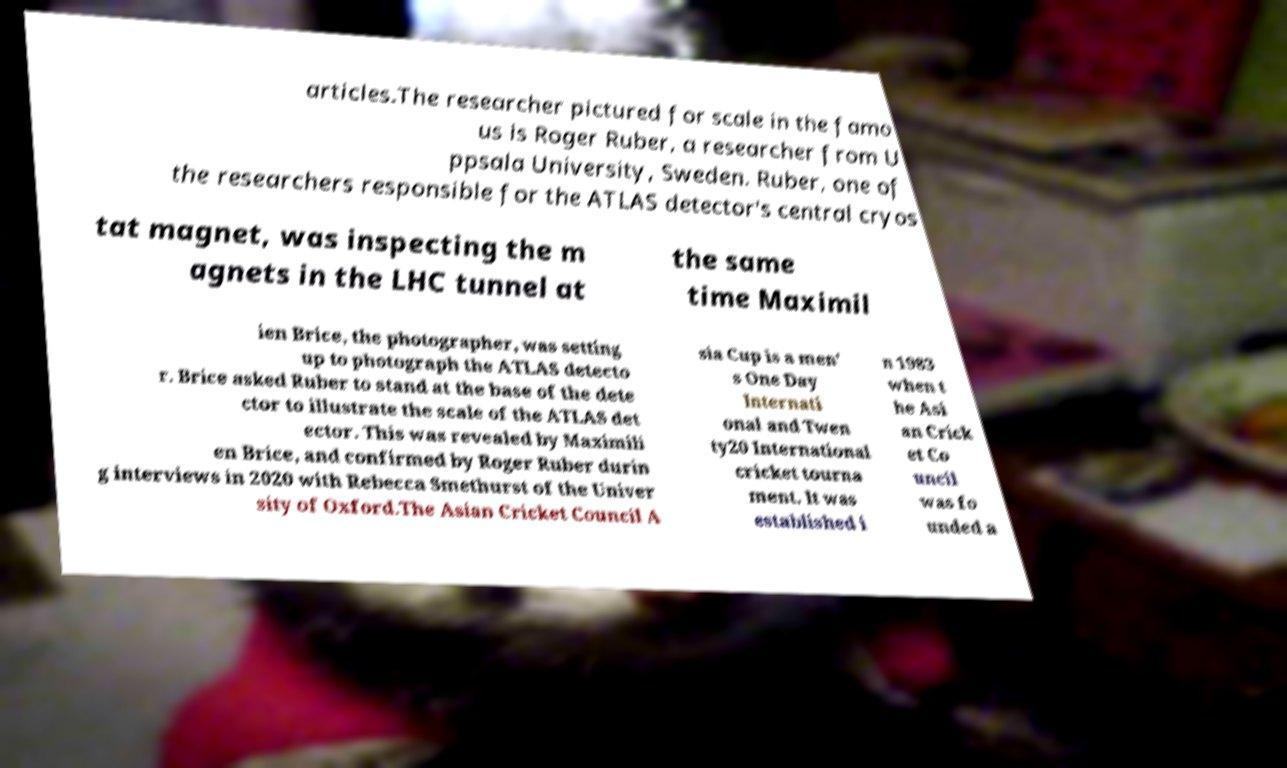For documentation purposes, I need the text within this image transcribed. Could you provide that? articles.The researcher pictured for scale in the famo us is Roger Ruber, a researcher from U ppsala University, Sweden. Ruber, one of the researchers responsible for the ATLAS detector's central cryos tat magnet, was inspecting the m agnets in the LHC tunnel at the same time Maximil ien Brice, the photographer, was setting up to photograph the ATLAS detecto r. Brice asked Ruber to stand at the base of the dete ctor to illustrate the scale of the ATLAS det ector. This was revealed by Maximili en Brice, and confirmed by Roger Ruber durin g interviews in 2020 with Rebecca Smethurst of the Univer sity of Oxford.The Asian Cricket Council A sia Cup is a men' s One Day Internati onal and Twen ty20 International cricket tourna ment. It was established i n 1983 when t he Asi an Crick et Co uncil was fo unded a 